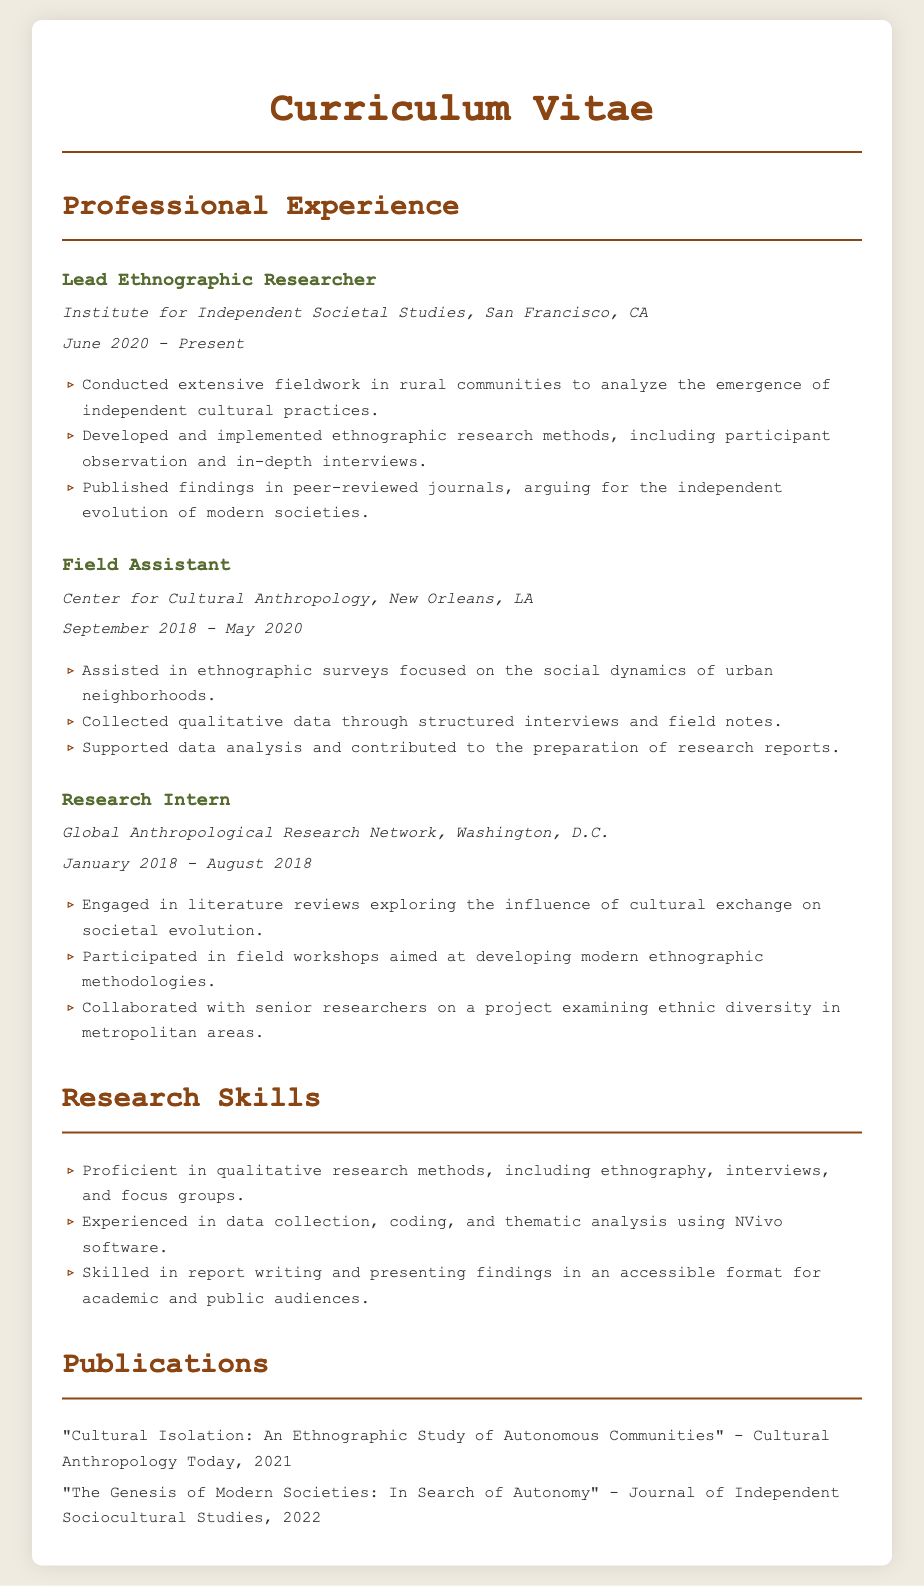what is the current position held? The document lists the current position as Lead Ethnographic Researcher.
Answer: Lead Ethnographic Researcher where is the Institute for Independent Societal Studies located? The location of the Institute is provided in the document as San Francisco, CA.
Answer: San Francisco, CA what year did the Field Assistant position start? The document indicates that the Field Assistant position started in September 2018.
Answer: September 2018 how many publications are listed? The document mentions two publications under the Publications section.
Answer: two which research software is mentioned in the document? The CV states the software used for data analysis is NVivo.
Answer: NVivo what is the focus of the fieldwork conducted by the Lead Ethnographic Researcher? The document outlines the focus of fieldwork as the emergence of independent cultural practices.
Answer: independent cultural practices which role involved literature reviews? The Research Intern role is identified as being involved in literature reviews.
Answer: Research Intern what type of interviews were conducted as a Field Assistant? The document specifies that structured interviews were used by the Field Assistant.
Answer: structured interviews when did the Research Intern position end? The document states that the Research Intern position ended in August 2018.
Answer: August 2018 